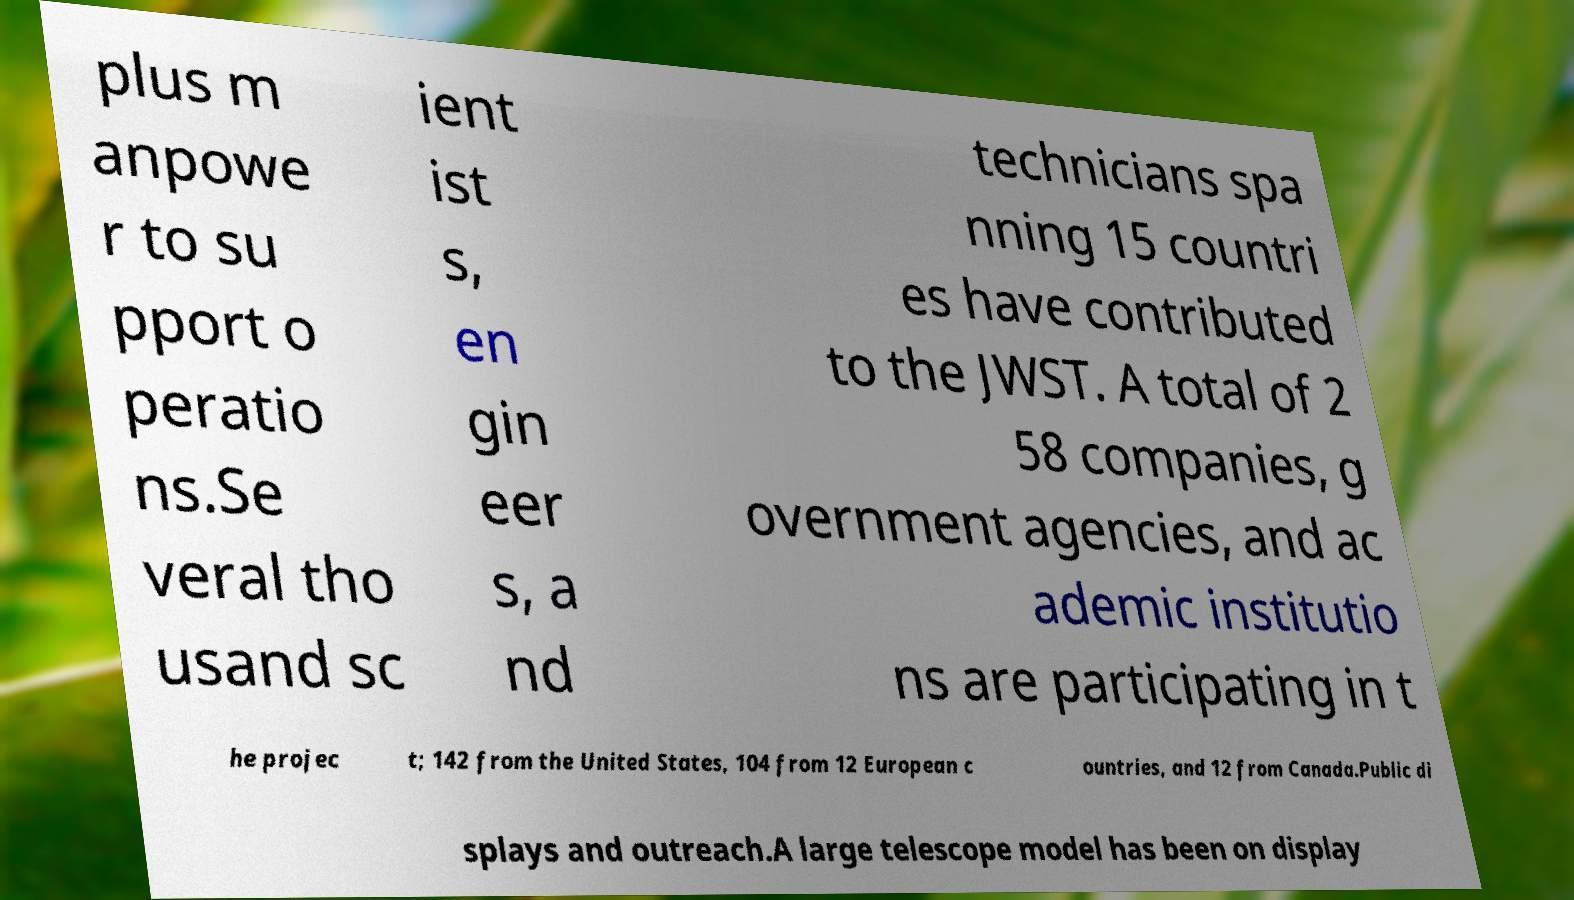For documentation purposes, I need the text within this image transcribed. Could you provide that? plus m anpowe r to su pport o peratio ns.Se veral tho usand sc ient ist s, en gin eer s, a nd technicians spa nning 15 countri es have contributed to the JWST. A total of 2 58 companies, g overnment agencies, and ac ademic institutio ns are participating in t he projec t; 142 from the United States, 104 from 12 European c ountries, and 12 from Canada.Public di splays and outreach.A large telescope model has been on display 